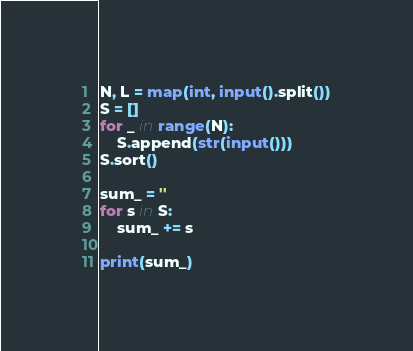Convert code to text. <code><loc_0><loc_0><loc_500><loc_500><_Python_>N, L = map(int, input().split())
S = []
for _ in range(N):
    S.append(str(input()))
S.sort()

sum_ = ''
for s in S:
    sum_ += s

print(sum_)</code> 